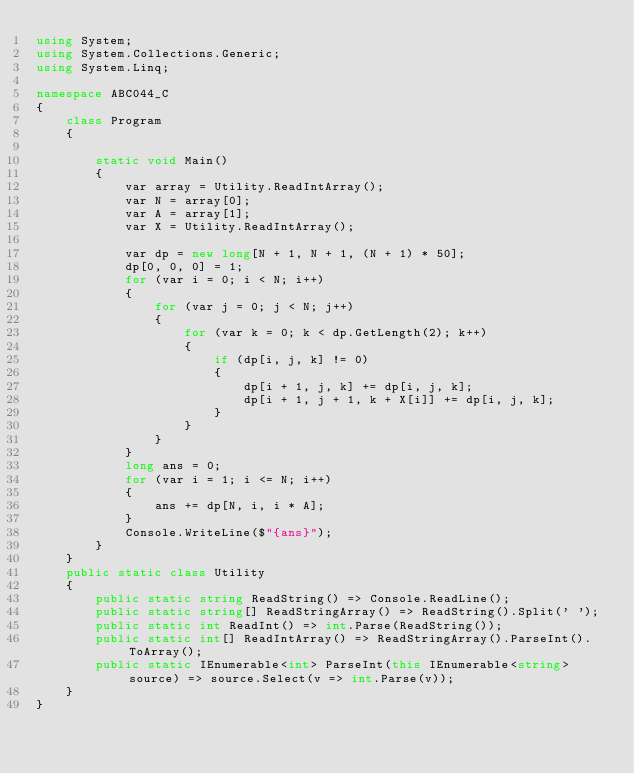<code> <loc_0><loc_0><loc_500><loc_500><_C#_>using System;
using System.Collections.Generic;
using System.Linq;

namespace ABC044_C
{
    class Program
    {

        static void Main()
        {
            var array = Utility.ReadIntArray();
            var N = array[0];
            var A = array[1];
            var X = Utility.ReadIntArray();

            var dp = new long[N + 1, N + 1, (N + 1) * 50];
            dp[0, 0, 0] = 1;
            for (var i = 0; i < N; i++)
            {
                for (var j = 0; j < N; j++)
                {
                    for (var k = 0; k < dp.GetLength(2); k++)
                    {
                        if (dp[i, j, k] != 0)
                        {
                            dp[i + 1, j, k] += dp[i, j, k];
                            dp[i + 1, j + 1, k + X[i]] += dp[i, j, k];
                        }
                    }
                }
            }
            long ans = 0;
            for (var i = 1; i <= N; i++)
            {
                ans += dp[N, i, i * A];
            }
            Console.WriteLine($"{ans}");
        }
    }
    public static class Utility
    {
        public static string ReadString() => Console.ReadLine();
        public static string[] ReadStringArray() => ReadString().Split(' ');
        public static int ReadInt() => int.Parse(ReadString());
        public static int[] ReadIntArray() => ReadStringArray().ParseInt().ToArray();
        public static IEnumerable<int> ParseInt(this IEnumerable<string> source) => source.Select(v => int.Parse(v));
    }
}
</code> 